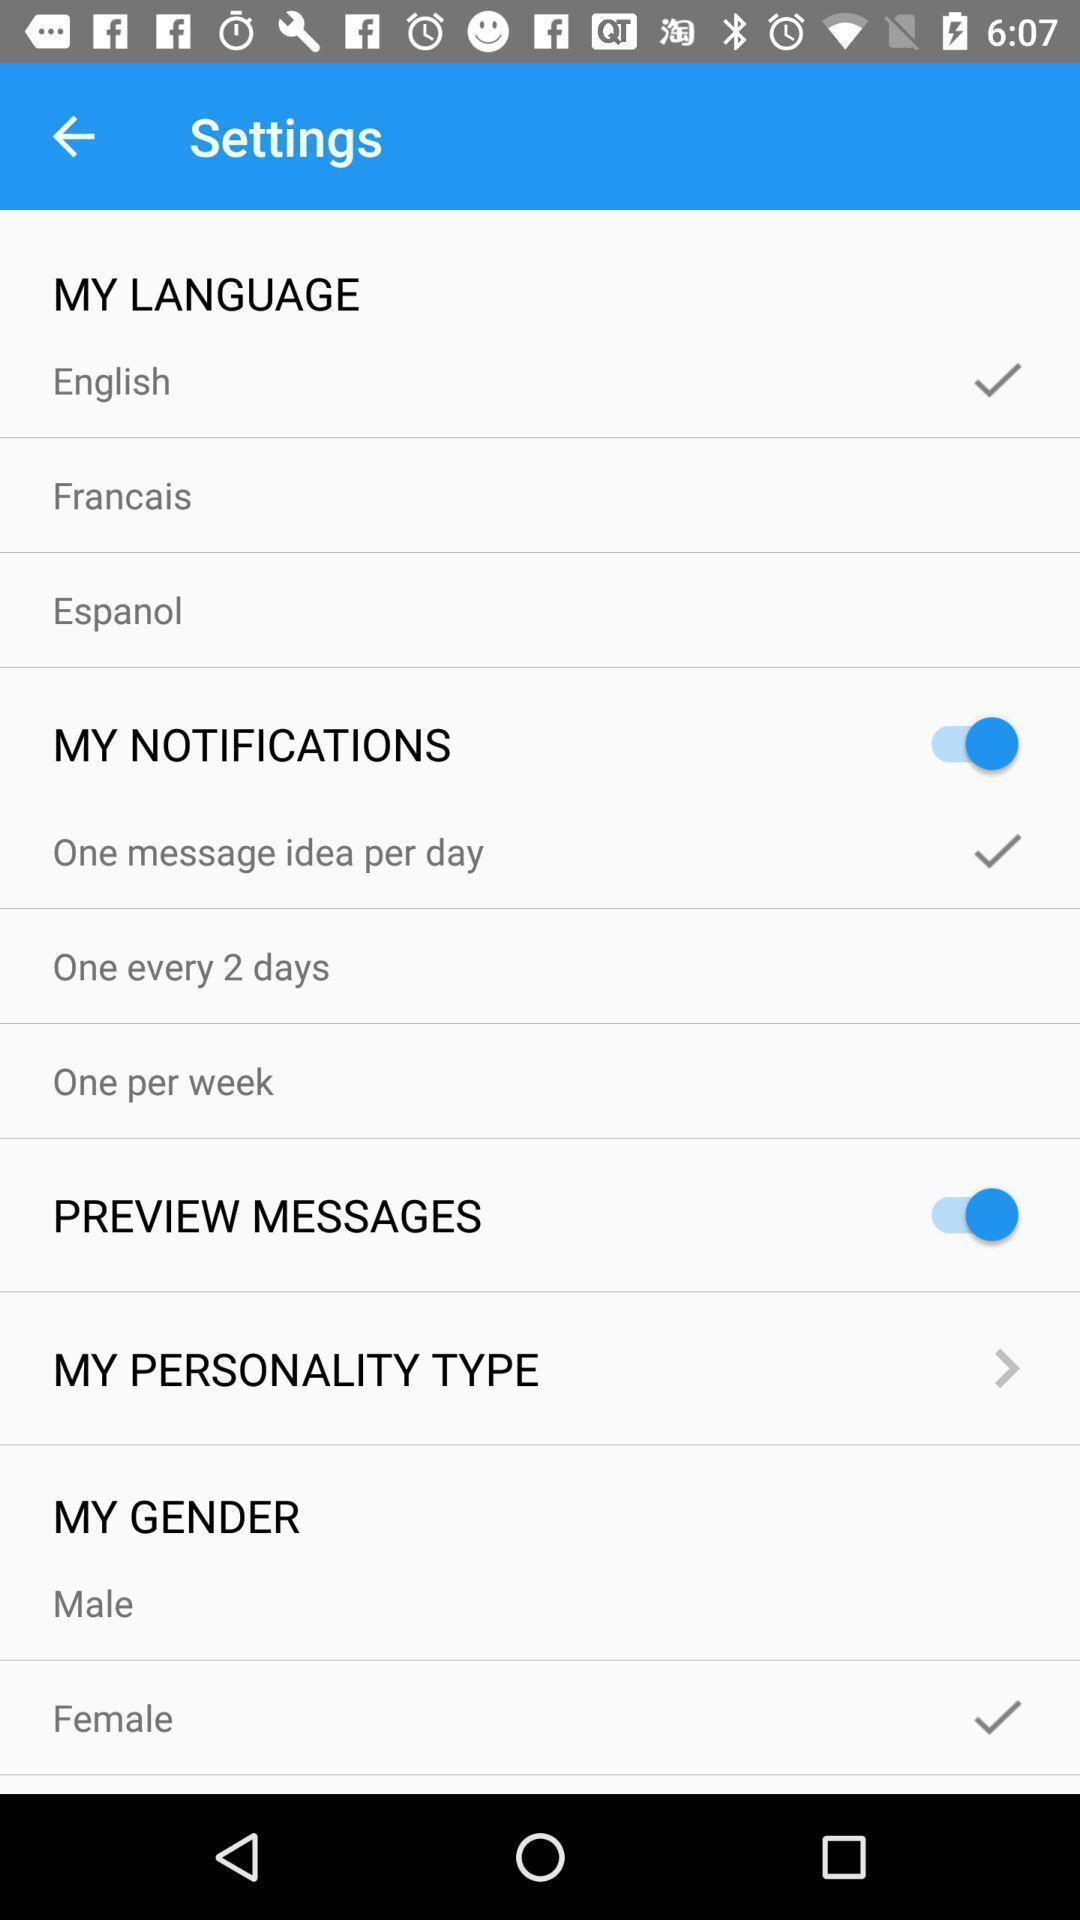What can you discern from this picture? Settings page with options. 